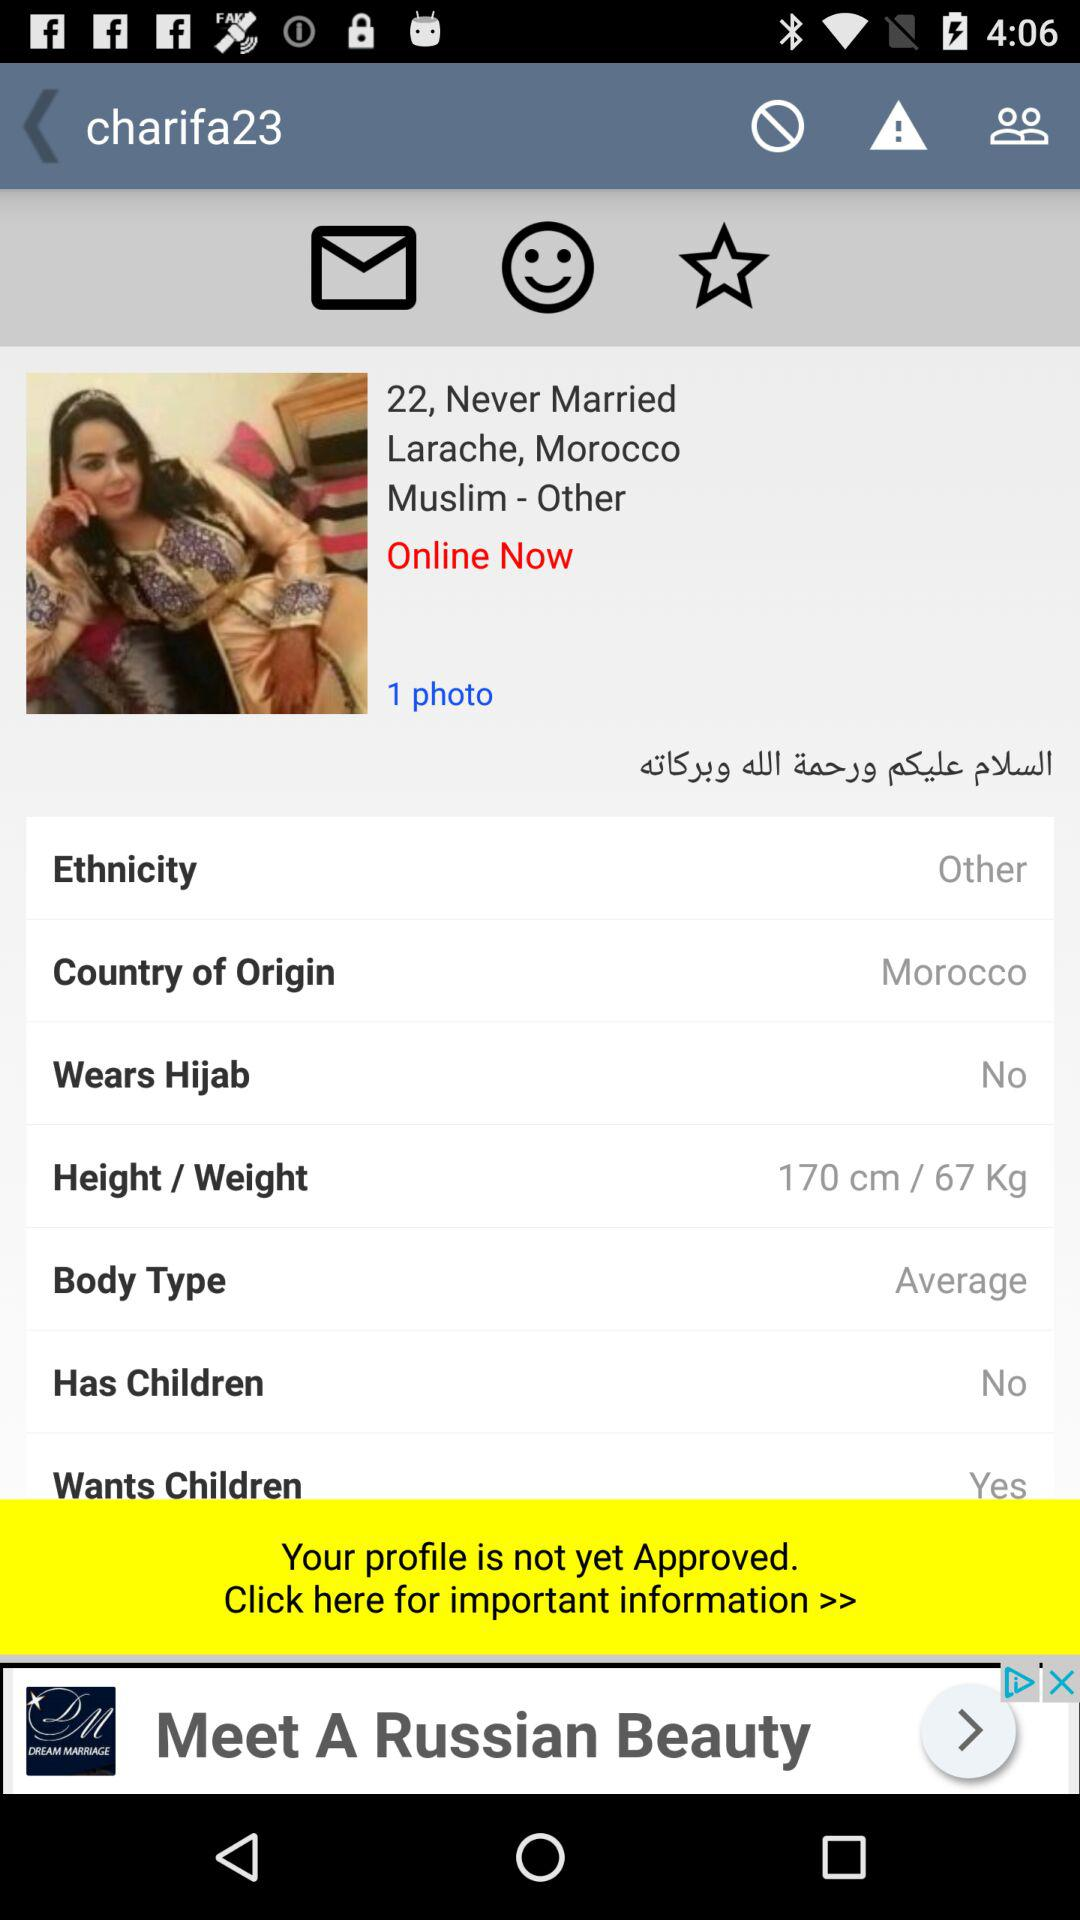What are the height and weight of the user? The height is 170 cm and the weight is 67 kg. 